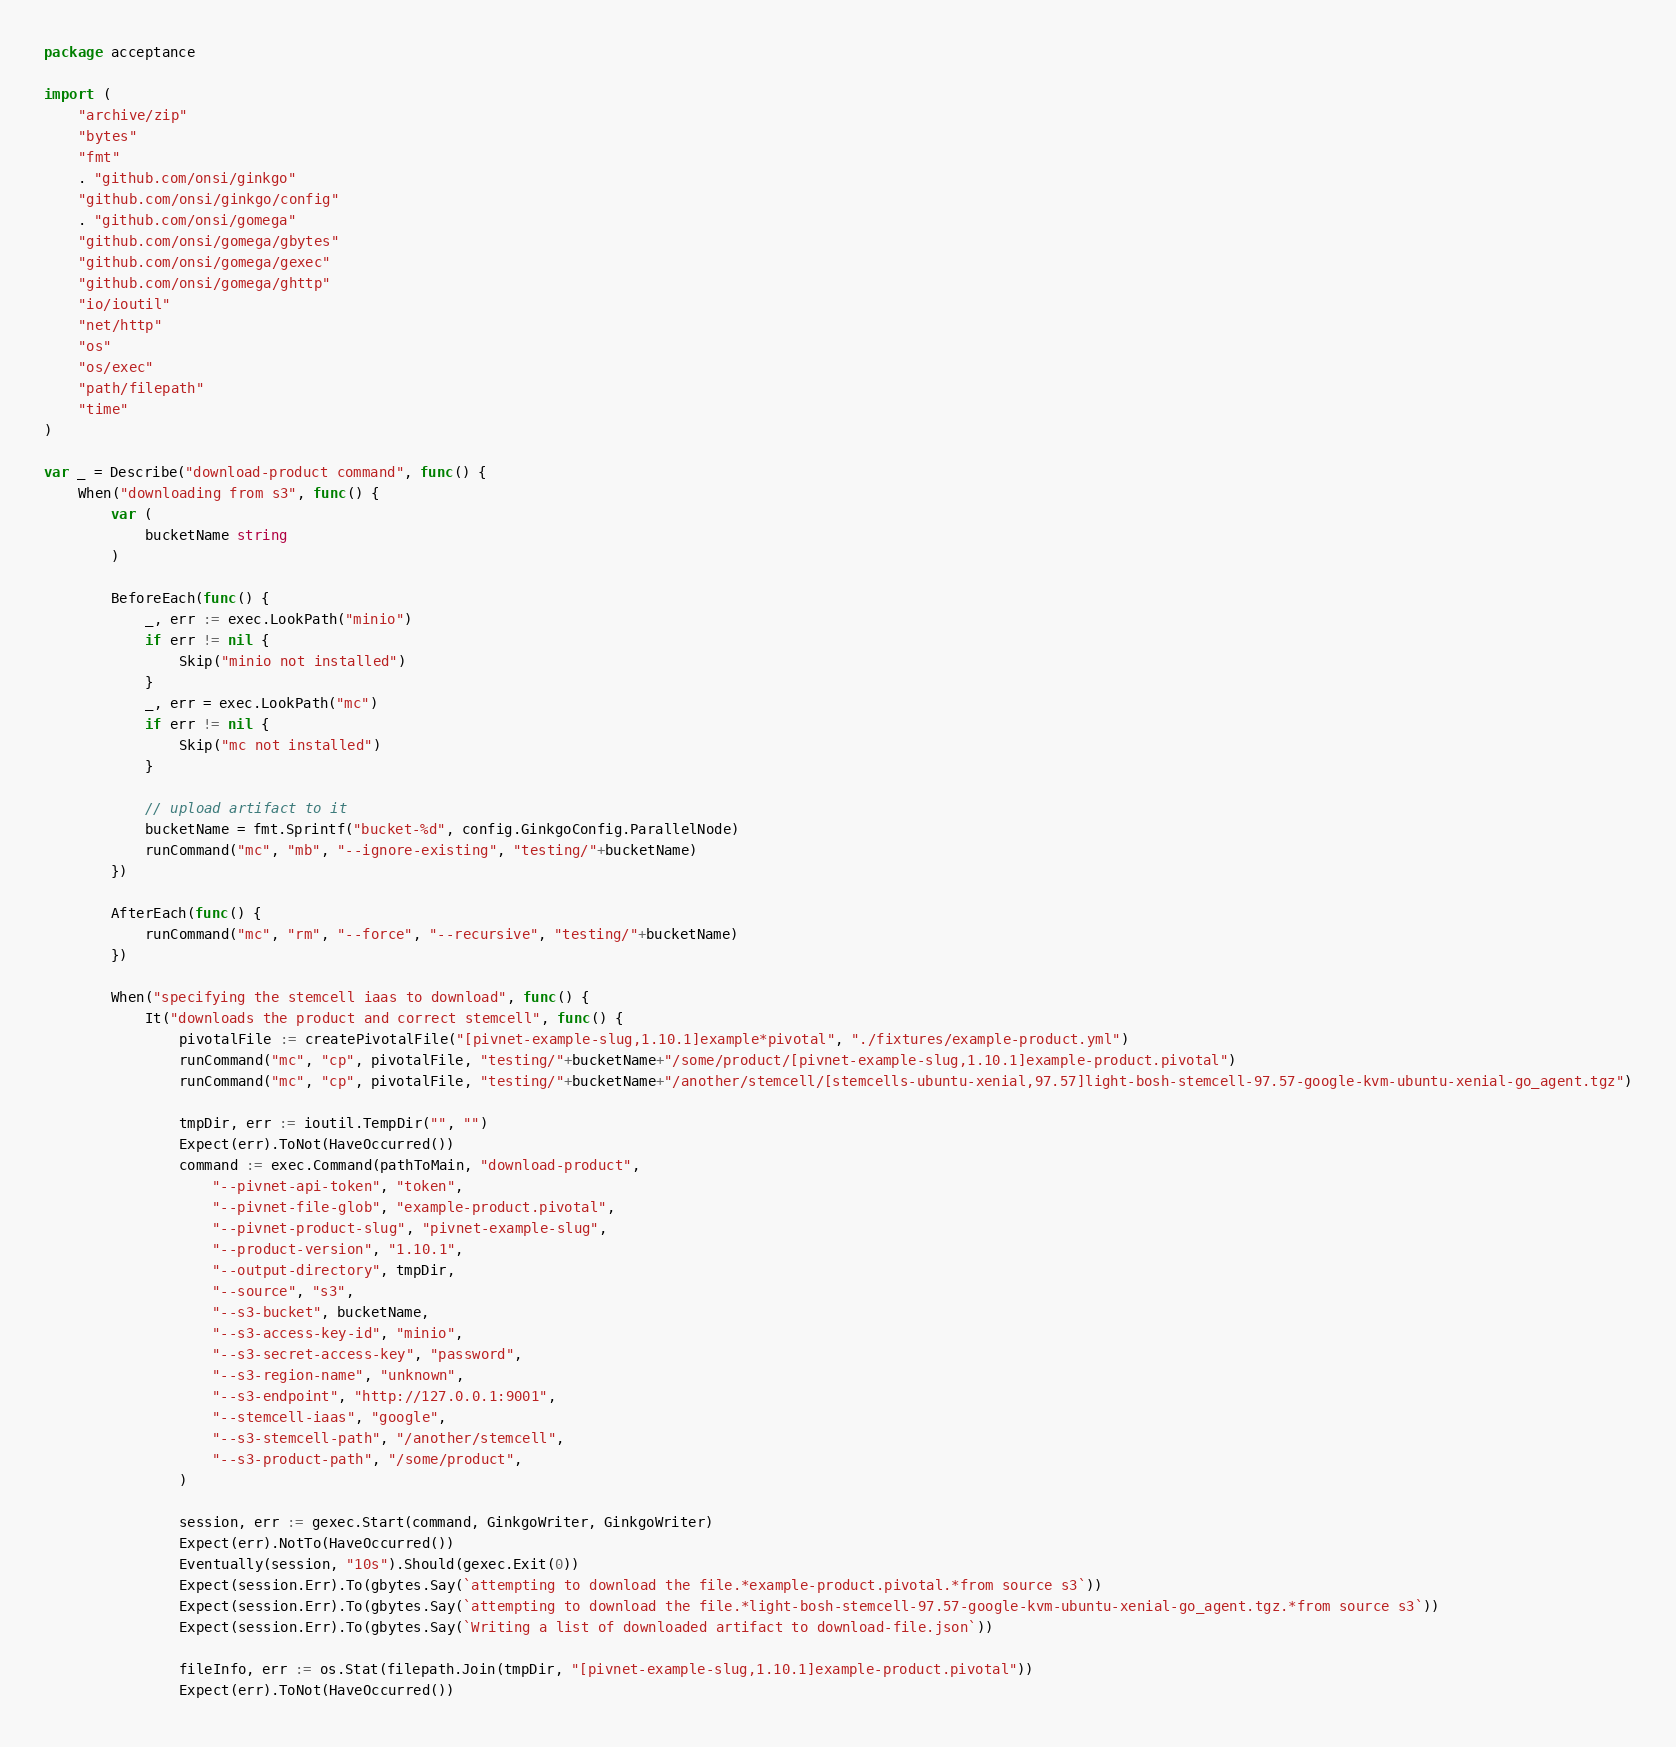<code> <loc_0><loc_0><loc_500><loc_500><_Go_>package acceptance

import (
	"archive/zip"
	"bytes"
	"fmt"
	. "github.com/onsi/ginkgo"
	"github.com/onsi/ginkgo/config"
	. "github.com/onsi/gomega"
	"github.com/onsi/gomega/gbytes"
	"github.com/onsi/gomega/gexec"
	"github.com/onsi/gomega/ghttp"
	"io/ioutil"
	"net/http"
	"os"
	"os/exec"
	"path/filepath"
	"time"
)

var _ = Describe("download-product command", func() {
	When("downloading from s3", func() {
		var (
			bucketName string
		)

		BeforeEach(func() {
			_, err := exec.LookPath("minio")
			if err != nil {
				Skip("minio not installed")
			}
			_, err = exec.LookPath("mc")
			if err != nil {
				Skip("mc not installed")
			}

			// upload artifact to it
			bucketName = fmt.Sprintf("bucket-%d", config.GinkgoConfig.ParallelNode)
			runCommand("mc", "mb", "--ignore-existing", "testing/"+bucketName)
		})

		AfterEach(func() {
			runCommand("mc", "rm", "--force", "--recursive", "testing/"+bucketName)
		})

		When("specifying the stemcell iaas to download", func() {
			It("downloads the product and correct stemcell", func() {
				pivotalFile := createPivotalFile("[pivnet-example-slug,1.10.1]example*pivotal", "./fixtures/example-product.yml")
				runCommand("mc", "cp", pivotalFile, "testing/"+bucketName+"/some/product/[pivnet-example-slug,1.10.1]example-product.pivotal")
				runCommand("mc", "cp", pivotalFile, "testing/"+bucketName+"/another/stemcell/[stemcells-ubuntu-xenial,97.57]light-bosh-stemcell-97.57-google-kvm-ubuntu-xenial-go_agent.tgz")

				tmpDir, err := ioutil.TempDir("", "")
				Expect(err).ToNot(HaveOccurred())
				command := exec.Command(pathToMain, "download-product",
					"--pivnet-api-token", "token",
					"--pivnet-file-glob", "example-product.pivotal",
					"--pivnet-product-slug", "pivnet-example-slug",
					"--product-version", "1.10.1",
					"--output-directory", tmpDir,
					"--source", "s3",
					"--s3-bucket", bucketName,
					"--s3-access-key-id", "minio",
					"--s3-secret-access-key", "password",
					"--s3-region-name", "unknown",
					"--s3-endpoint", "http://127.0.0.1:9001",
					"--stemcell-iaas", "google",
					"--s3-stemcell-path", "/another/stemcell",
					"--s3-product-path", "/some/product",
				)

				session, err := gexec.Start(command, GinkgoWriter, GinkgoWriter)
				Expect(err).NotTo(HaveOccurred())
				Eventually(session, "10s").Should(gexec.Exit(0))
				Expect(session.Err).To(gbytes.Say(`attempting to download the file.*example-product.pivotal.*from source s3`))
				Expect(session.Err).To(gbytes.Say(`attempting to download the file.*light-bosh-stemcell-97.57-google-kvm-ubuntu-xenial-go_agent.tgz.*from source s3`))
				Expect(session.Err).To(gbytes.Say(`Writing a list of downloaded artifact to download-file.json`))

				fileInfo, err := os.Stat(filepath.Join(tmpDir, "[pivnet-example-slug,1.10.1]example-product.pivotal"))
				Expect(err).ToNot(HaveOccurred())
</code> 